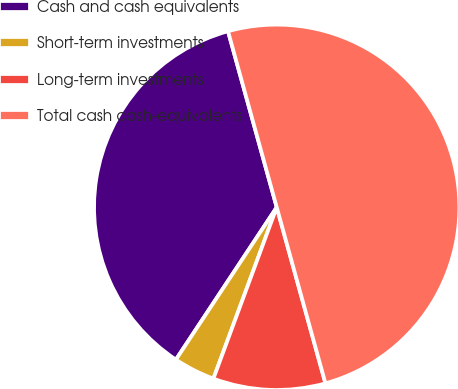Convert chart. <chart><loc_0><loc_0><loc_500><loc_500><pie_chart><fcel>Cash and cash equivalents<fcel>Short-term investments<fcel>Long-term investments<fcel>Total cash cash-equivalents<nl><fcel>36.4%<fcel>3.67%<fcel>9.93%<fcel>50.0%<nl></chart> 